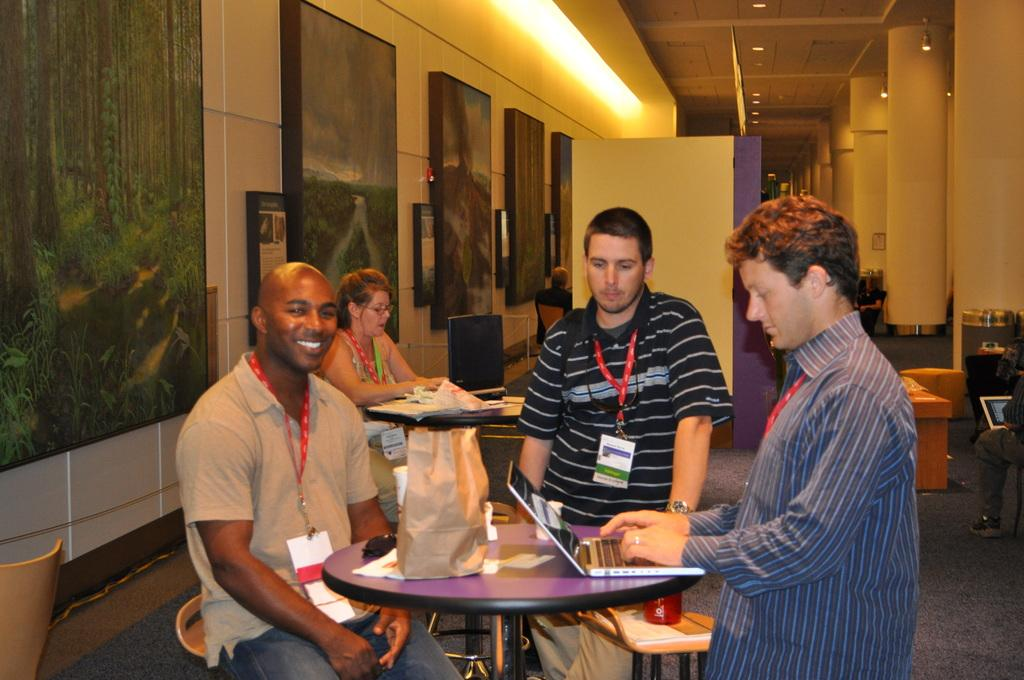What is present in the image that serves as a background or barrier? There is a wall in the image. What objects can be seen hanging on the wall? There are photo frames in the image. What are the people in the image doing? There are people sitting on chairs in the image. What piece of furniture is present in the image? There is a table in the image. What is covering the table? There is a cover on the table. What electronic device is on the table? There is a laptop on the table. Can you describe the flesh of the people swimming in the image? There are no people swimming in the image; it features people sitting on chairs. What type of stretch is the wall performing in the image? The wall is not performing any stretch; it is a stationary background or barrier. 